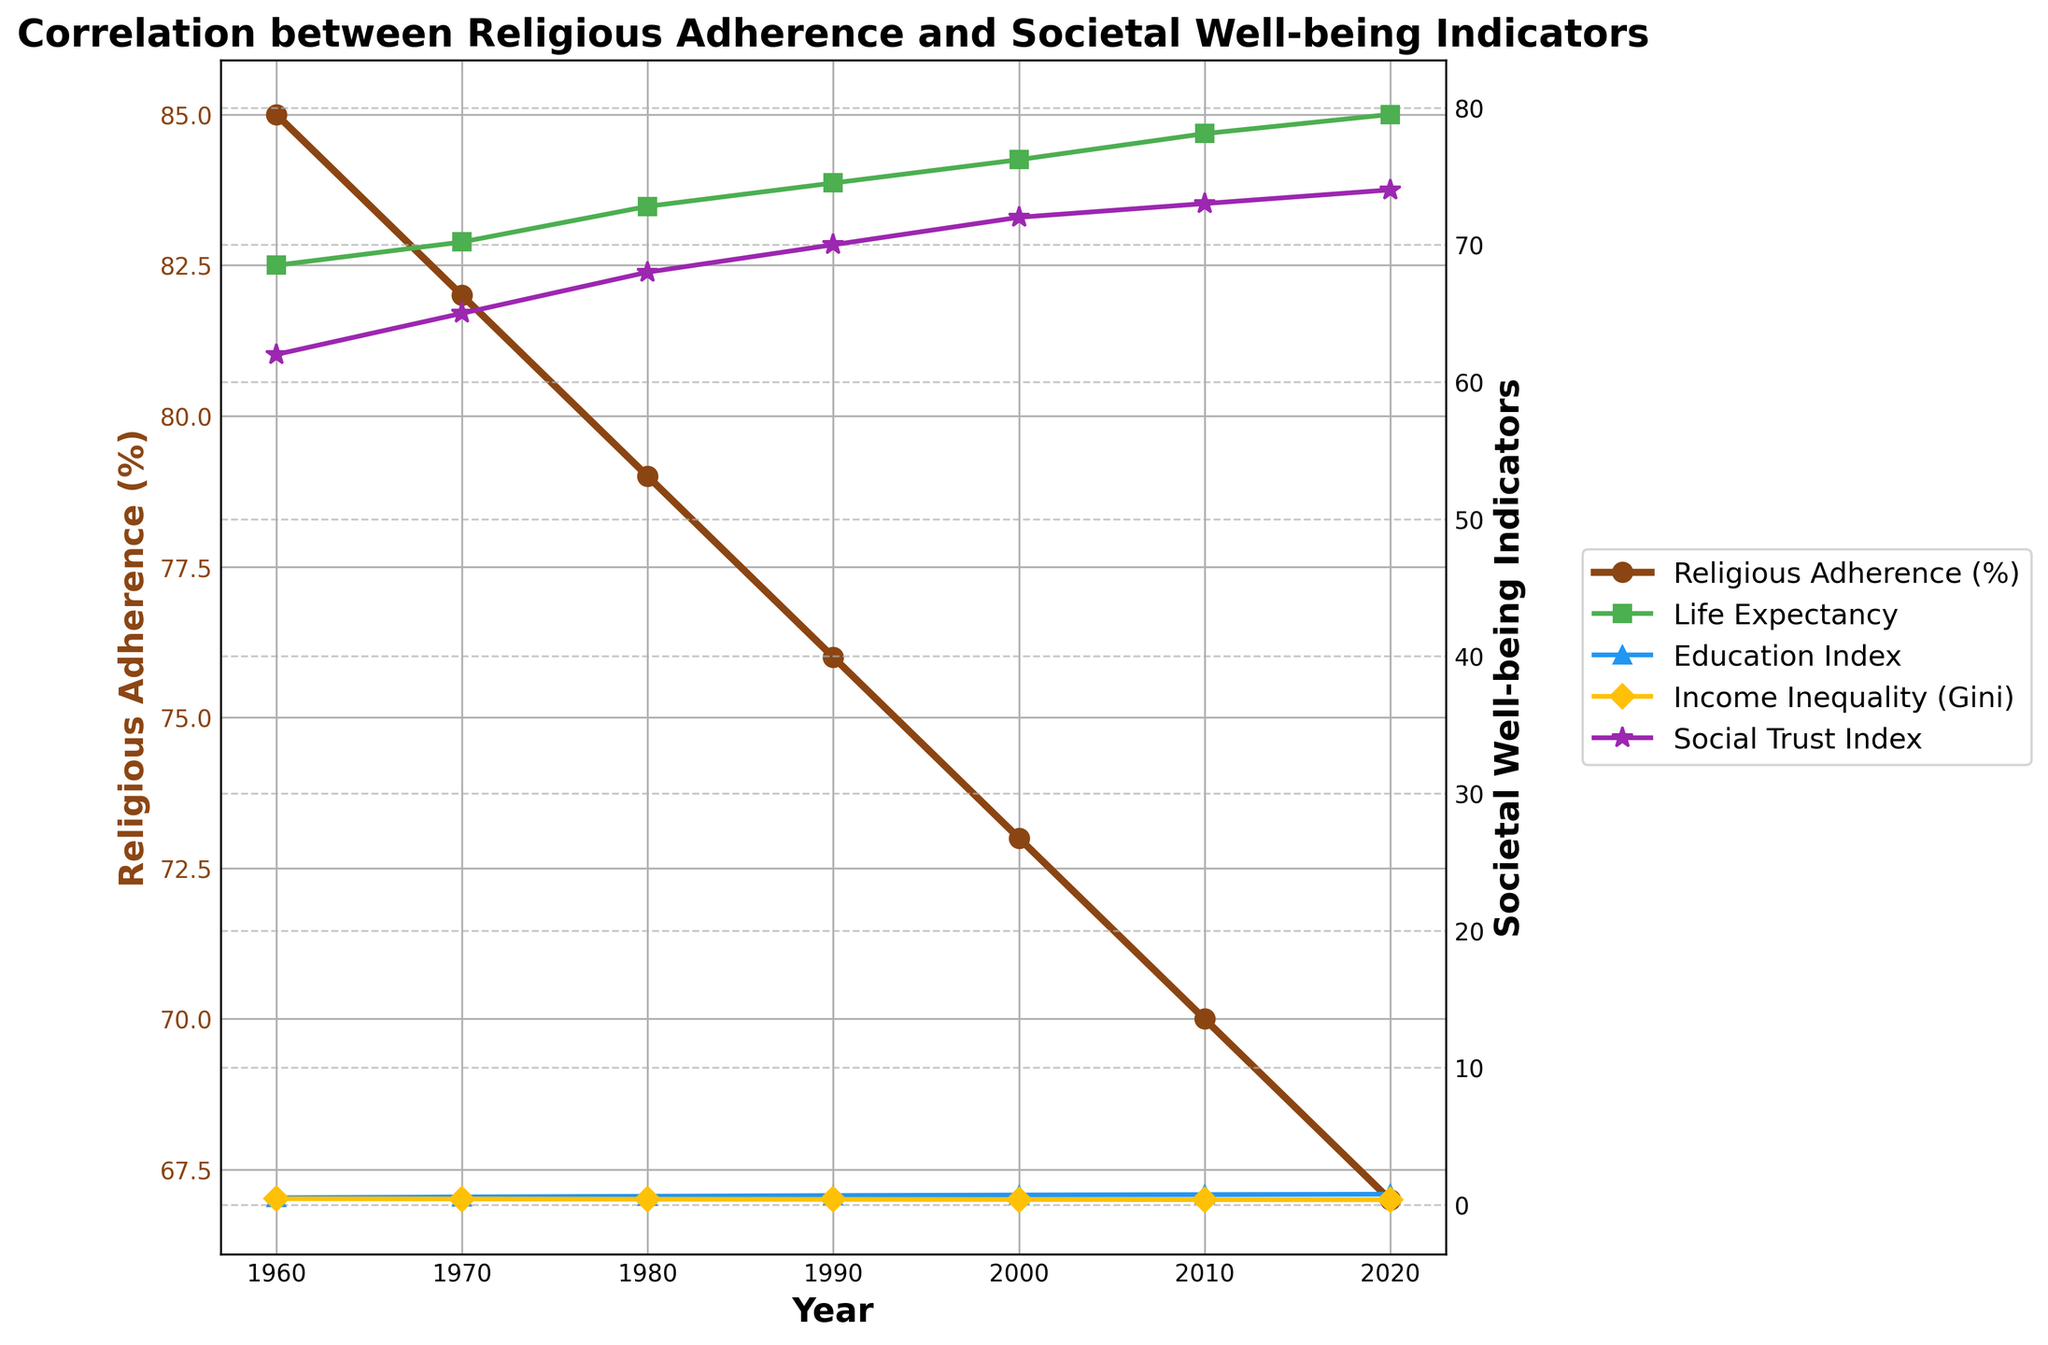What trend is observed in Religious Adherence (%) over the years? To identify the trend in Religious Adherence (%), we examine its values from 1960 to 2020. The graph shows a consistent decline from 85% to 67%. This trend indicates a decrease in religious adherence over time.
Answer: Decreasing How does the Social Trust Index change relative to Life Expectancy from 1960 to 2020? To compare the Social Trust Index and Life Expectancy, we observe their values from 1960 to 2020. The Social Trust Index increases from 62 to 74, and Life Expectancy also increases from 68.5 to 79.5 years. Both indicators show an upward trend.
Answer: Both increase Between 1970 and 2000, which year had the highest Education Index? To find the highest Education Index between 1970 and 2000, we compare the Education Index values for 1970 (0.58), 1980 (0.63), 1990 (0.68), and 2000 (0.72). The highest value is in the year 2000.
Answer: 2000 By how much did the Gini (Income Inequality) Index decrease from 1960 to 2020? We subtract the Gini value in 2020 (0.37) from the Gini value in 1960 (0.45), giving us 0.45 - 0.37. This shows the total decrease over the period.
Answer: 0.08 What is the difference between Life Expectancy in 1980 and Education Index in 2000? To find the difference, we subtract the Education Index value in 2000 (0.72) from the Life Expectancy value in 1980 (72.8 years). Hence, 72.8 - 0.72 = 72.08.
Answer: 72.08 Which indicator has the smallest change from 1960 to 2020? We compare the change in all indicators from 1960 to 2020. Religious Adherence changes from 85% to 67% (18%), Life Expectancy from 68.5 to 79.5 (11), Education Index from 0.52 to 0.78 (0.26), Gini from 0.45 to 0.37 (0.08), and Social Trust Index from 62 to 74 (12). The smallest change is in the Gini Index.
Answer: Gini Index Does Religious Adherence (%) and Education Index ever move in the same direction simultaneously? To determine this, we check if both values are increasing or decreasing together at any point. Between 1960 and 2020, Religious Adherence always decreases while the Education Index always increases. Hence, they do not move in the same direction simultaneously.
Answer: No 